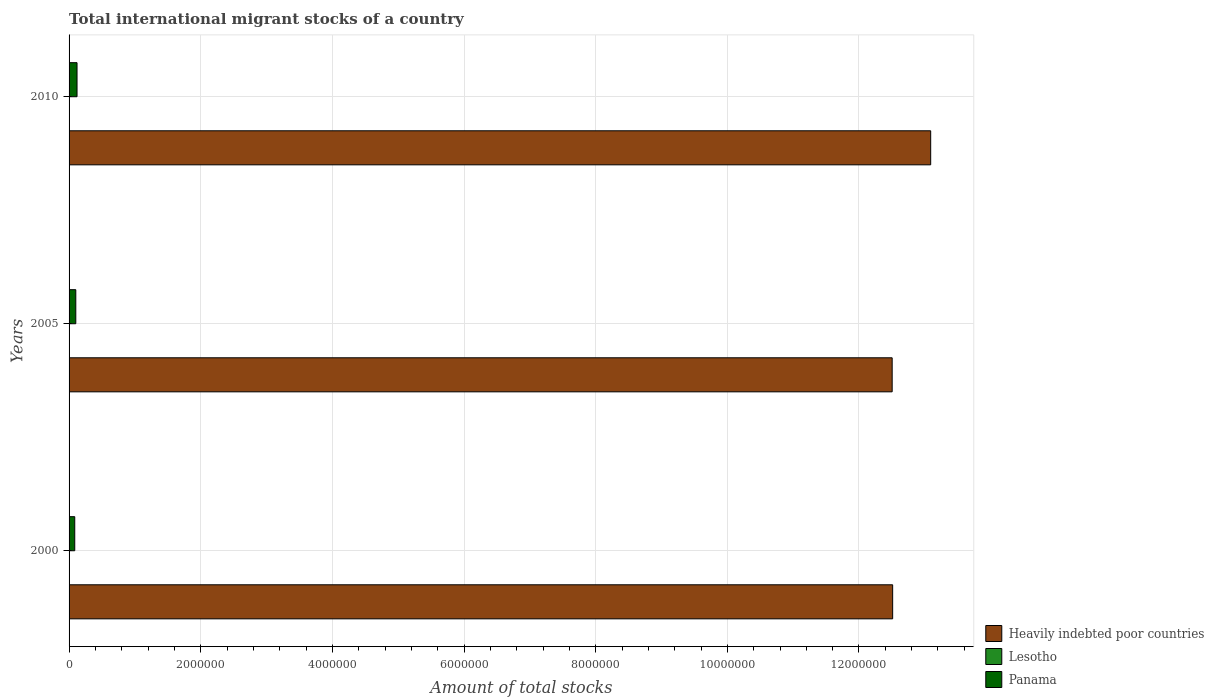How many groups of bars are there?
Your answer should be compact. 3. Are the number of bars on each tick of the Y-axis equal?
Give a very brief answer. Yes. In how many cases, is the number of bars for a given year not equal to the number of legend labels?
Offer a terse response. 0. What is the amount of total stocks in in Heavily indebted poor countries in 2010?
Make the answer very short. 1.31e+07. Across all years, what is the maximum amount of total stocks in in Lesotho?
Keep it short and to the point. 6328. Across all years, what is the minimum amount of total stocks in in Heavily indebted poor countries?
Make the answer very short. 1.25e+07. In which year was the amount of total stocks in in Heavily indebted poor countries maximum?
Keep it short and to the point. 2010. In which year was the amount of total stocks in in Panama minimum?
Your answer should be very brief. 2000. What is the total amount of total stocks in in Heavily indebted poor countries in the graph?
Offer a very short reply. 3.81e+07. What is the difference between the amount of total stocks in in Lesotho in 2005 and that in 2010?
Make the answer very short. -81. What is the difference between the amount of total stocks in in Heavily indebted poor countries in 2010 and the amount of total stocks in in Panama in 2000?
Your response must be concise. 1.30e+07. What is the average amount of total stocks in in Panama per year?
Provide a short and direct response. 1.03e+05. In the year 2000, what is the difference between the amount of total stocks in in Heavily indebted poor countries and amount of total stocks in in Lesotho?
Offer a terse response. 1.25e+07. In how many years, is the amount of total stocks in in Panama greater than 11600000 ?
Your answer should be very brief. 0. What is the ratio of the amount of total stocks in in Lesotho in 2000 to that in 2005?
Offer a very short reply. 0.99. What is the difference between the highest and the second highest amount of total stocks in in Heavily indebted poor countries?
Keep it short and to the point. 5.78e+05. What is the difference between the highest and the lowest amount of total stocks in in Heavily indebted poor countries?
Your answer should be very brief. 5.85e+05. In how many years, is the amount of total stocks in in Panama greater than the average amount of total stocks in in Panama taken over all years?
Your answer should be compact. 1. Is the sum of the amount of total stocks in in Lesotho in 2005 and 2010 greater than the maximum amount of total stocks in in Heavily indebted poor countries across all years?
Your answer should be compact. No. What does the 2nd bar from the top in 2005 represents?
Your answer should be compact. Lesotho. What does the 1st bar from the bottom in 2010 represents?
Your response must be concise. Heavily indebted poor countries. Is it the case that in every year, the sum of the amount of total stocks in in Lesotho and amount of total stocks in in Panama is greater than the amount of total stocks in in Heavily indebted poor countries?
Make the answer very short. No. How many bars are there?
Keep it short and to the point. 9. How many years are there in the graph?
Offer a very short reply. 3. Does the graph contain grids?
Your answer should be compact. Yes. How many legend labels are there?
Ensure brevity in your answer.  3. What is the title of the graph?
Give a very brief answer. Total international migrant stocks of a country. What is the label or title of the X-axis?
Keep it short and to the point. Amount of total stocks. What is the label or title of the Y-axis?
Provide a short and direct response. Years. What is the Amount of total stocks of Heavily indebted poor countries in 2000?
Your answer should be compact. 1.25e+07. What is the Amount of total stocks in Lesotho in 2000?
Offer a terse response. 6167. What is the Amount of total stocks in Panama in 2000?
Provide a short and direct response. 8.64e+04. What is the Amount of total stocks of Heavily indebted poor countries in 2005?
Provide a succinct answer. 1.25e+07. What is the Amount of total stocks in Lesotho in 2005?
Give a very brief answer. 6247. What is the Amount of total stocks of Panama in 2005?
Provide a succinct answer. 1.02e+05. What is the Amount of total stocks in Heavily indebted poor countries in 2010?
Make the answer very short. 1.31e+07. What is the Amount of total stocks in Lesotho in 2010?
Your answer should be very brief. 6328. What is the Amount of total stocks in Panama in 2010?
Offer a terse response. 1.21e+05. Across all years, what is the maximum Amount of total stocks in Heavily indebted poor countries?
Provide a succinct answer. 1.31e+07. Across all years, what is the maximum Amount of total stocks of Lesotho?
Your answer should be very brief. 6328. Across all years, what is the maximum Amount of total stocks in Panama?
Provide a short and direct response. 1.21e+05. Across all years, what is the minimum Amount of total stocks in Heavily indebted poor countries?
Offer a terse response. 1.25e+07. Across all years, what is the minimum Amount of total stocks in Lesotho?
Give a very brief answer. 6167. Across all years, what is the minimum Amount of total stocks in Panama?
Offer a terse response. 8.64e+04. What is the total Amount of total stocks of Heavily indebted poor countries in the graph?
Your answer should be very brief. 3.81e+07. What is the total Amount of total stocks in Lesotho in the graph?
Give a very brief answer. 1.87e+04. What is the total Amount of total stocks of Panama in the graph?
Your answer should be very brief. 3.10e+05. What is the difference between the Amount of total stocks of Heavily indebted poor countries in 2000 and that in 2005?
Give a very brief answer. 7519. What is the difference between the Amount of total stocks of Lesotho in 2000 and that in 2005?
Your answer should be compact. -80. What is the difference between the Amount of total stocks of Panama in 2000 and that in 2005?
Give a very brief answer. -1.59e+04. What is the difference between the Amount of total stocks in Heavily indebted poor countries in 2000 and that in 2010?
Offer a very short reply. -5.78e+05. What is the difference between the Amount of total stocks in Lesotho in 2000 and that in 2010?
Keep it short and to the point. -161. What is the difference between the Amount of total stocks in Panama in 2000 and that in 2010?
Provide a short and direct response. -3.46e+04. What is the difference between the Amount of total stocks of Heavily indebted poor countries in 2005 and that in 2010?
Offer a terse response. -5.85e+05. What is the difference between the Amount of total stocks in Lesotho in 2005 and that in 2010?
Offer a very short reply. -81. What is the difference between the Amount of total stocks in Panama in 2005 and that in 2010?
Offer a very short reply. -1.88e+04. What is the difference between the Amount of total stocks in Heavily indebted poor countries in 2000 and the Amount of total stocks in Lesotho in 2005?
Provide a succinct answer. 1.25e+07. What is the difference between the Amount of total stocks in Heavily indebted poor countries in 2000 and the Amount of total stocks in Panama in 2005?
Give a very brief answer. 1.24e+07. What is the difference between the Amount of total stocks of Lesotho in 2000 and the Amount of total stocks of Panama in 2005?
Make the answer very short. -9.61e+04. What is the difference between the Amount of total stocks in Heavily indebted poor countries in 2000 and the Amount of total stocks in Lesotho in 2010?
Provide a succinct answer. 1.25e+07. What is the difference between the Amount of total stocks of Heavily indebted poor countries in 2000 and the Amount of total stocks of Panama in 2010?
Keep it short and to the point. 1.24e+07. What is the difference between the Amount of total stocks of Lesotho in 2000 and the Amount of total stocks of Panama in 2010?
Provide a succinct answer. -1.15e+05. What is the difference between the Amount of total stocks of Heavily indebted poor countries in 2005 and the Amount of total stocks of Lesotho in 2010?
Ensure brevity in your answer.  1.25e+07. What is the difference between the Amount of total stocks of Heavily indebted poor countries in 2005 and the Amount of total stocks of Panama in 2010?
Your response must be concise. 1.24e+07. What is the difference between the Amount of total stocks of Lesotho in 2005 and the Amount of total stocks of Panama in 2010?
Your response must be concise. -1.15e+05. What is the average Amount of total stocks in Heavily indebted poor countries per year?
Ensure brevity in your answer.  1.27e+07. What is the average Amount of total stocks in Lesotho per year?
Offer a very short reply. 6247.33. What is the average Amount of total stocks of Panama per year?
Give a very brief answer. 1.03e+05. In the year 2000, what is the difference between the Amount of total stocks in Heavily indebted poor countries and Amount of total stocks in Lesotho?
Provide a succinct answer. 1.25e+07. In the year 2000, what is the difference between the Amount of total stocks of Heavily indebted poor countries and Amount of total stocks of Panama?
Your response must be concise. 1.24e+07. In the year 2000, what is the difference between the Amount of total stocks in Lesotho and Amount of total stocks in Panama?
Offer a very short reply. -8.02e+04. In the year 2005, what is the difference between the Amount of total stocks in Heavily indebted poor countries and Amount of total stocks in Lesotho?
Ensure brevity in your answer.  1.25e+07. In the year 2005, what is the difference between the Amount of total stocks in Heavily indebted poor countries and Amount of total stocks in Panama?
Provide a succinct answer. 1.24e+07. In the year 2005, what is the difference between the Amount of total stocks in Lesotho and Amount of total stocks in Panama?
Make the answer very short. -9.60e+04. In the year 2010, what is the difference between the Amount of total stocks in Heavily indebted poor countries and Amount of total stocks in Lesotho?
Offer a very short reply. 1.31e+07. In the year 2010, what is the difference between the Amount of total stocks of Heavily indebted poor countries and Amount of total stocks of Panama?
Make the answer very short. 1.30e+07. In the year 2010, what is the difference between the Amount of total stocks of Lesotho and Amount of total stocks of Panama?
Ensure brevity in your answer.  -1.15e+05. What is the ratio of the Amount of total stocks in Heavily indebted poor countries in 2000 to that in 2005?
Your response must be concise. 1. What is the ratio of the Amount of total stocks in Lesotho in 2000 to that in 2005?
Give a very brief answer. 0.99. What is the ratio of the Amount of total stocks of Panama in 2000 to that in 2005?
Your answer should be compact. 0.84. What is the ratio of the Amount of total stocks of Heavily indebted poor countries in 2000 to that in 2010?
Your answer should be compact. 0.96. What is the ratio of the Amount of total stocks in Lesotho in 2000 to that in 2010?
Provide a short and direct response. 0.97. What is the ratio of the Amount of total stocks of Panama in 2000 to that in 2010?
Offer a very short reply. 0.71. What is the ratio of the Amount of total stocks in Heavily indebted poor countries in 2005 to that in 2010?
Offer a terse response. 0.96. What is the ratio of the Amount of total stocks in Lesotho in 2005 to that in 2010?
Provide a short and direct response. 0.99. What is the ratio of the Amount of total stocks of Panama in 2005 to that in 2010?
Provide a short and direct response. 0.84. What is the difference between the highest and the second highest Amount of total stocks in Heavily indebted poor countries?
Provide a short and direct response. 5.78e+05. What is the difference between the highest and the second highest Amount of total stocks of Panama?
Make the answer very short. 1.88e+04. What is the difference between the highest and the lowest Amount of total stocks in Heavily indebted poor countries?
Give a very brief answer. 5.85e+05. What is the difference between the highest and the lowest Amount of total stocks of Lesotho?
Your answer should be very brief. 161. What is the difference between the highest and the lowest Amount of total stocks in Panama?
Give a very brief answer. 3.46e+04. 